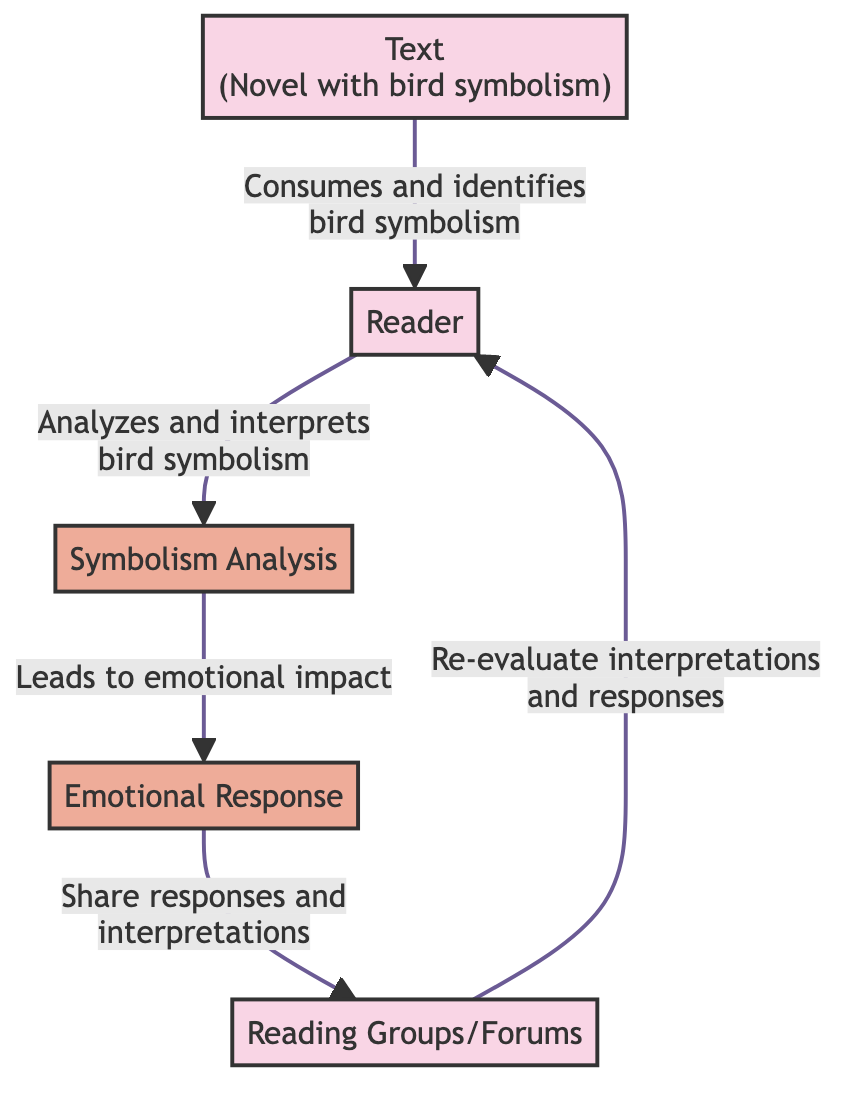What is the primary entity in the diagram? The primary entity represented in the diagram is the "Text" which refers to the novel containing bird symbolism.
Answer: Text How many entities are present in the diagram? The diagram contains five distinct entities: Text, Reader, Symbolism Analysis, Emotion, and Reading Groups.
Answer: 5 What flow occurs from the Reader to the Symbolism Analysis? The flow from the Reader to the Symbolism Analysis indicates that the reader analyzes and interprets the meaning behind bird symbolism.
Answer: Analyzes and interprets bird symbolism Which entity is influenced by Emotion? The readers in "Reading Groups" are influenced by the "Emotion" entity as they share their emotional responses and interpretations.
Answer: Reading Groups What is the relationship between the Emotion and Reading Groups? The relationship indicates that readers share their emotional responses and interpretations in reading groups or forums.
Answer: Share responses and interpretations How does the Reader re-evaluate their interpretations? The reader interacts with discussions in reading groups, which can lead them to re-evaluate their interpretations and emotional responses towards the text.
Answer: Re-evaluate interpretations and responses What process occurs after the Symbolism Analysis? The process following Symbolism Analysis is the emotional response elicited from the reader as a result of their analysis.
Answer: Emotional impact How does the flow from Text to Reader influence the analysis? The Reader consumes the Text and identifies bird symbolism, which is crucial for them to begin the analysis and interpretation process.
Answer: Reader consumes the text What type of diagram is presented here? This diagram is a Data Flow Diagram (DFD), emphasizing the flow of information between different entities regarding reader interpretation of bird symbolism.
Answer: Data Flow Diagram 